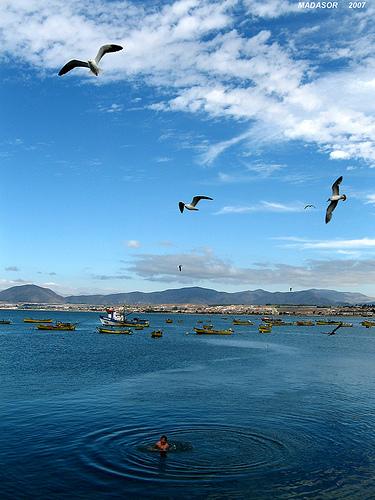Is the swimmer far from shore?
Quick response, please. Yes. Do you see any humans?
Quick response, please. Yes. How many birds are in the sky?
Be succinct. 5. 